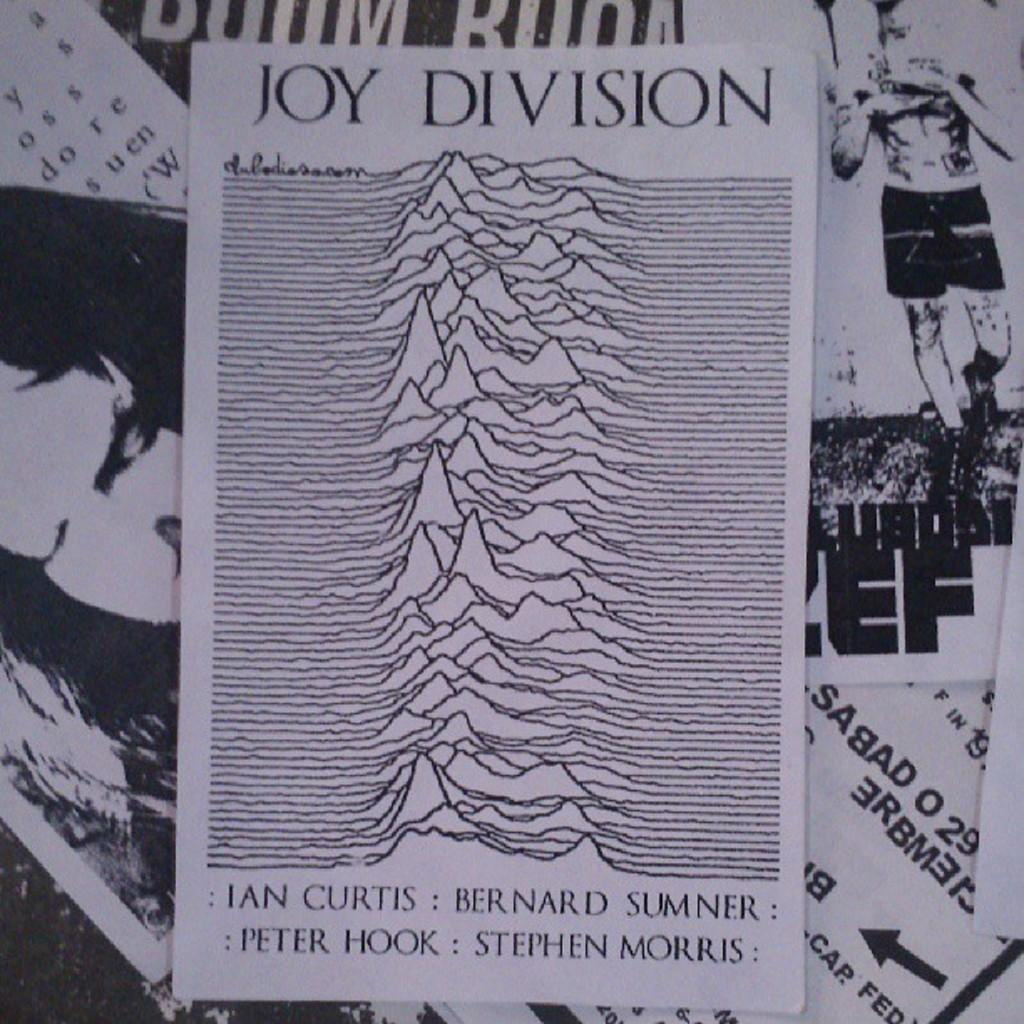Provide a one-sentence caption for the provided image. Joy Division includes pictures and words on the paper. 